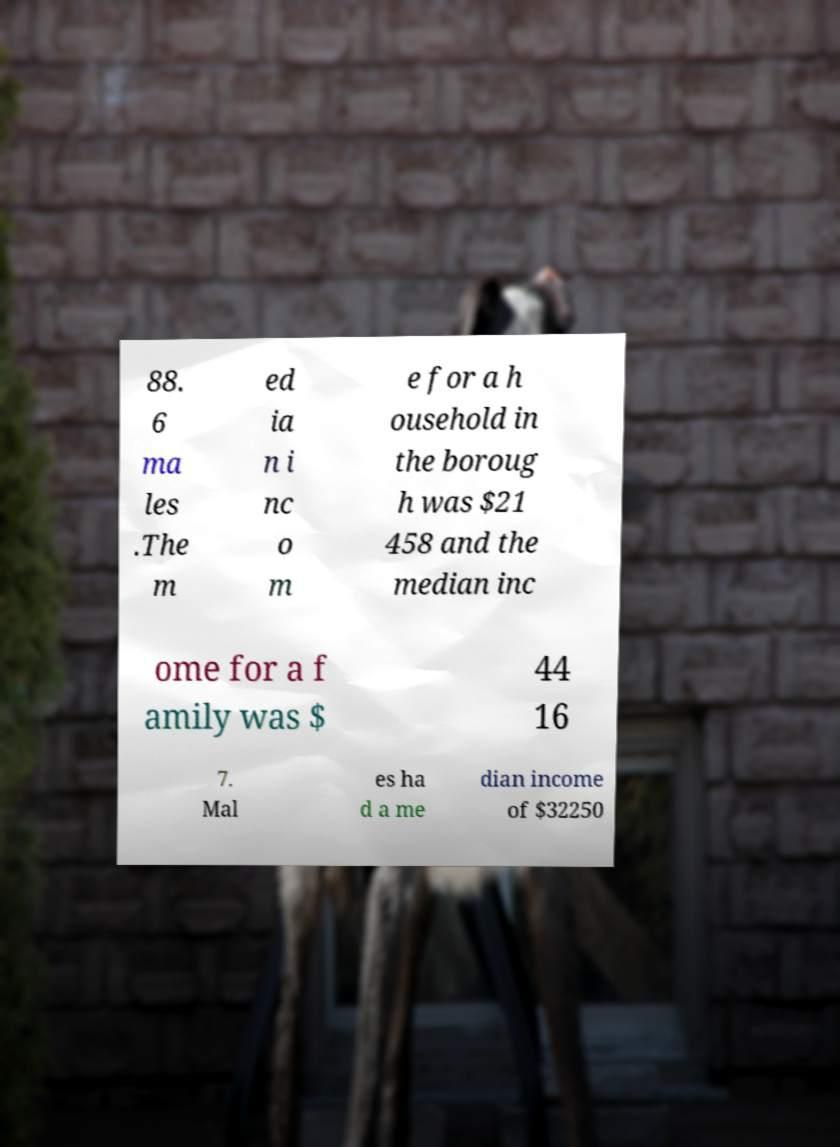For documentation purposes, I need the text within this image transcribed. Could you provide that? 88. 6 ma les .The m ed ia n i nc o m e for a h ousehold in the boroug h was $21 458 and the median inc ome for a f amily was $ 44 16 7. Mal es ha d a me dian income of $32250 